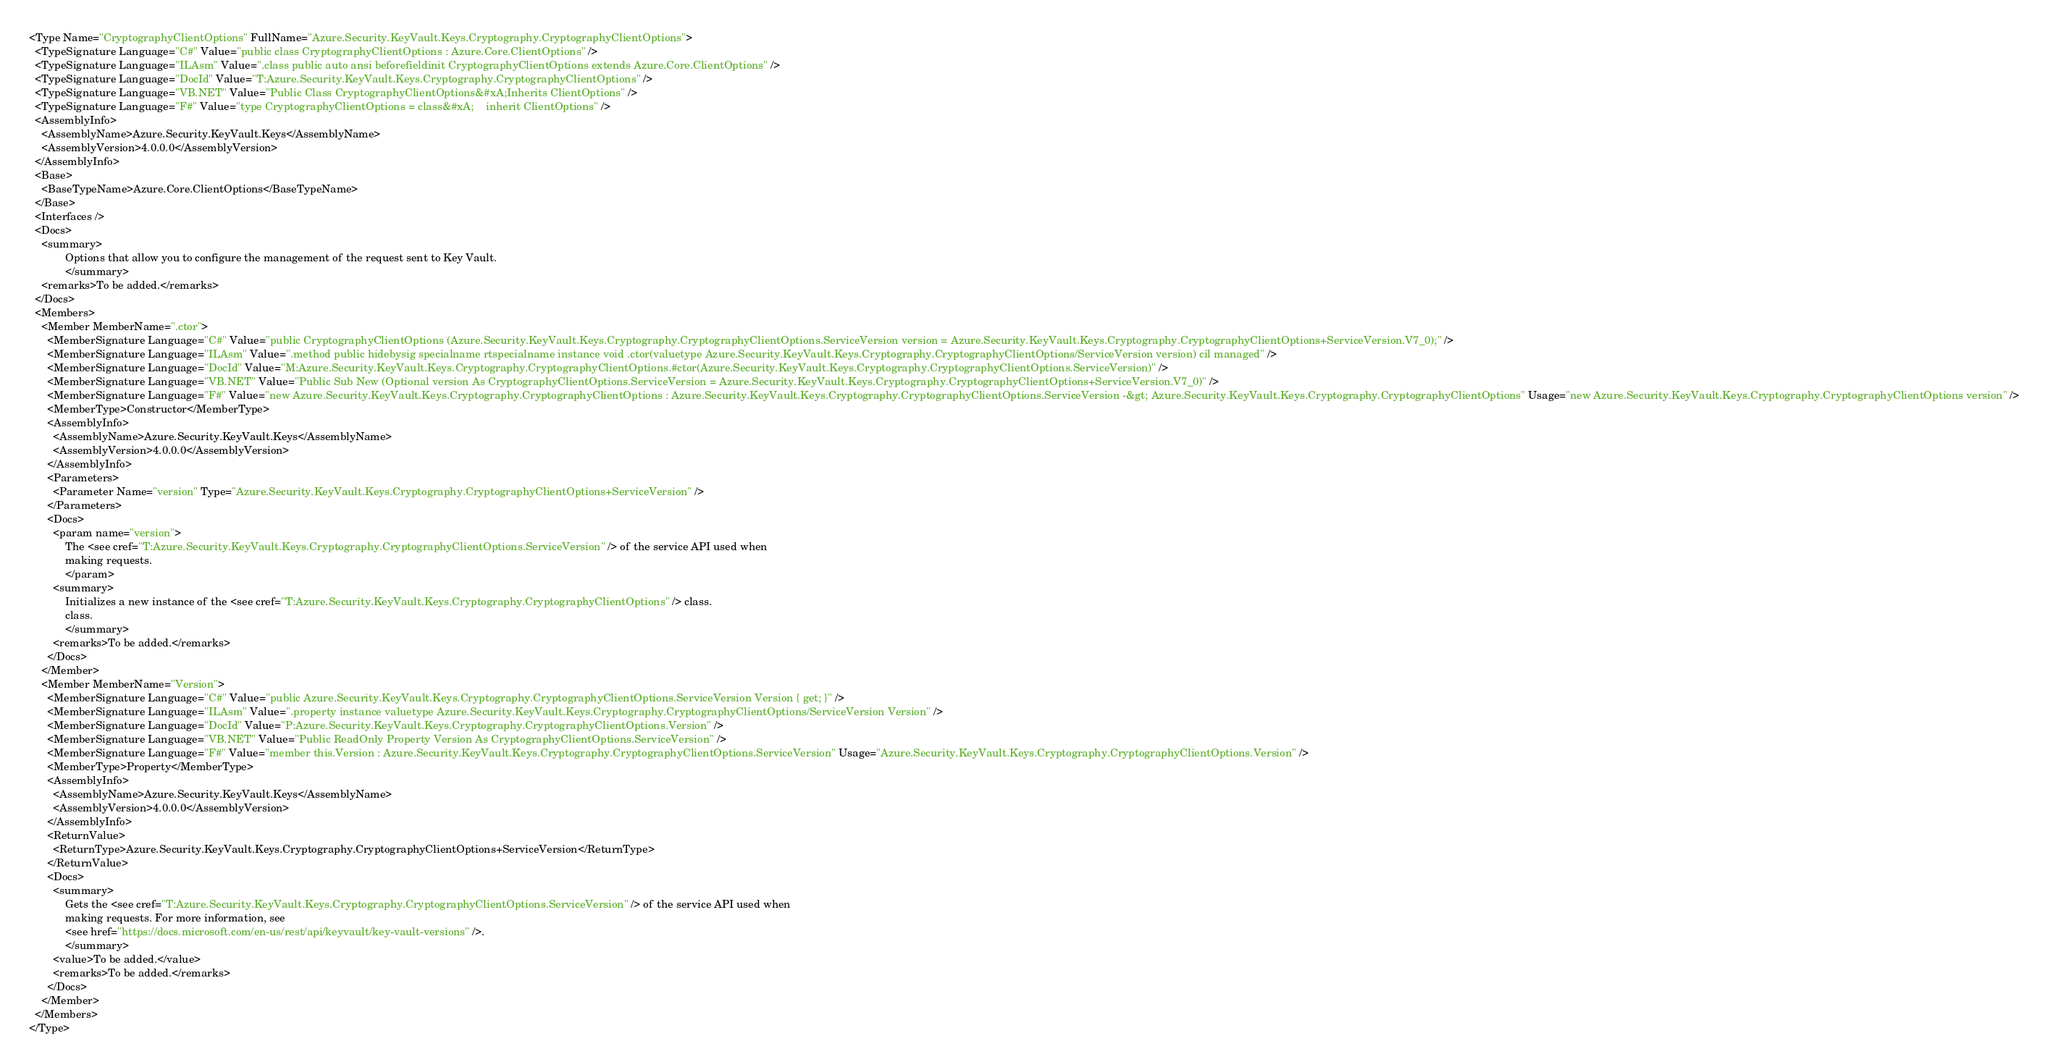Convert code to text. <code><loc_0><loc_0><loc_500><loc_500><_XML_><Type Name="CryptographyClientOptions" FullName="Azure.Security.KeyVault.Keys.Cryptography.CryptographyClientOptions">
  <TypeSignature Language="C#" Value="public class CryptographyClientOptions : Azure.Core.ClientOptions" />
  <TypeSignature Language="ILAsm" Value=".class public auto ansi beforefieldinit CryptographyClientOptions extends Azure.Core.ClientOptions" />
  <TypeSignature Language="DocId" Value="T:Azure.Security.KeyVault.Keys.Cryptography.CryptographyClientOptions" />
  <TypeSignature Language="VB.NET" Value="Public Class CryptographyClientOptions&#xA;Inherits ClientOptions" />
  <TypeSignature Language="F#" Value="type CryptographyClientOptions = class&#xA;    inherit ClientOptions" />
  <AssemblyInfo>
    <AssemblyName>Azure.Security.KeyVault.Keys</AssemblyName>
    <AssemblyVersion>4.0.0.0</AssemblyVersion>
  </AssemblyInfo>
  <Base>
    <BaseTypeName>Azure.Core.ClientOptions</BaseTypeName>
  </Base>
  <Interfaces />
  <Docs>
    <summary>
            Options that allow you to configure the management of the request sent to Key Vault.
            </summary>
    <remarks>To be added.</remarks>
  </Docs>
  <Members>
    <Member MemberName=".ctor">
      <MemberSignature Language="C#" Value="public CryptographyClientOptions (Azure.Security.KeyVault.Keys.Cryptography.CryptographyClientOptions.ServiceVersion version = Azure.Security.KeyVault.Keys.Cryptography.CryptographyClientOptions+ServiceVersion.V7_0);" />
      <MemberSignature Language="ILAsm" Value=".method public hidebysig specialname rtspecialname instance void .ctor(valuetype Azure.Security.KeyVault.Keys.Cryptography.CryptographyClientOptions/ServiceVersion version) cil managed" />
      <MemberSignature Language="DocId" Value="M:Azure.Security.KeyVault.Keys.Cryptography.CryptographyClientOptions.#ctor(Azure.Security.KeyVault.Keys.Cryptography.CryptographyClientOptions.ServiceVersion)" />
      <MemberSignature Language="VB.NET" Value="Public Sub New (Optional version As CryptographyClientOptions.ServiceVersion = Azure.Security.KeyVault.Keys.Cryptography.CryptographyClientOptions+ServiceVersion.V7_0)" />
      <MemberSignature Language="F#" Value="new Azure.Security.KeyVault.Keys.Cryptography.CryptographyClientOptions : Azure.Security.KeyVault.Keys.Cryptography.CryptographyClientOptions.ServiceVersion -&gt; Azure.Security.KeyVault.Keys.Cryptography.CryptographyClientOptions" Usage="new Azure.Security.KeyVault.Keys.Cryptography.CryptographyClientOptions version" />
      <MemberType>Constructor</MemberType>
      <AssemblyInfo>
        <AssemblyName>Azure.Security.KeyVault.Keys</AssemblyName>
        <AssemblyVersion>4.0.0.0</AssemblyVersion>
      </AssemblyInfo>
      <Parameters>
        <Parameter Name="version" Type="Azure.Security.KeyVault.Keys.Cryptography.CryptographyClientOptions+ServiceVersion" />
      </Parameters>
      <Docs>
        <param name="version">
            The <see cref="T:Azure.Security.KeyVault.Keys.Cryptography.CryptographyClientOptions.ServiceVersion" /> of the service API used when
            making requests.
            </param>
        <summary>
            Initializes a new instance of the <see cref="T:Azure.Security.KeyVault.Keys.Cryptography.CryptographyClientOptions" /> class.
            class.
            </summary>
        <remarks>To be added.</remarks>
      </Docs>
    </Member>
    <Member MemberName="Version">
      <MemberSignature Language="C#" Value="public Azure.Security.KeyVault.Keys.Cryptography.CryptographyClientOptions.ServiceVersion Version { get; }" />
      <MemberSignature Language="ILAsm" Value=".property instance valuetype Azure.Security.KeyVault.Keys.Cryptography.CryptographyClientOptions/ServiceVersion Version" />
      <MemberSignature Language="DocId" Value="P:Azure.Security.KeyVault.Keys.Cryptography.CryptographyClientOptions.Version" />
      <MemberSignature Language="VB.NET" Value="Public ReadOnly Property Version As CryptographyClientOptions.ServiceVersion" />
      <MemberSignature Language="F#" Value="member this.Version : Azure.Security.KeyVault.Keys.Cryptography.CryptographyClientOptions.ServiceVersion" Usage="Azure.Security.KeyVault.Keys.Cryptography.CryptographyClientOptions.Version" />
      <MemberType>Property</MemberType>
      <AssemblyInfo>
        <AssemblyName>Azure.Security.KeyVault.Keys</AssemblyName>
        <AssemblyVersion>4.0.0.0</AssemblyVersion>
      </AssemblyInfo>
      <ReturnValue>
        <ReturnType>Azure.Security.KeyVault.Keys.Cryptography.CryptographyClientOptions+ServiceVersion</ReturnType>
      </ReturnValue>
      <Docs>
        <summary>
            Gets the <see cref="T:Azure.Security.KeyVault.Keys.Cryptography.CryptographyClientOptions.ServiceVersion" /> of the service API used when
            making requests. For more information, see
            <see href="https://docs.microsoft.com/en-us/rest/api/keyvault/key-vault-versions" />.
            </summary>
        <value>To be added.</value>
        <remarks>To be added.</remarks>
      </Docs>
    </Member>
  </Members>
</Type>
</code> 